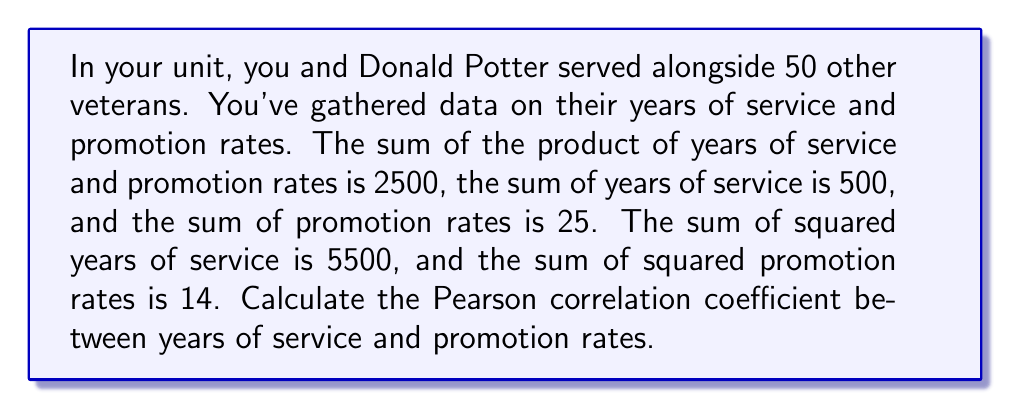Help me with this question. To calculate the Pearson correlation coefficient, we'll use the formula:

$$ r = \frac{n\sum xy - \sum x \sum y}{\sqrt{[n\sum x^2 - (\sum x)^2][n\sum y^2 - (\sum y)^2]}} $$

Where:
$x$ = years of service
$y$ = promotion rates
$n$ = number of veterans = 52 (including you and Donald Potter)

Given:
$\sum xy = 2500$
$\sum x = 500$
$\sum y = 25$
$\sum x^2 = 5500$
$\sum y^2 = 14$

Step 1: Calculate the numerator
$n\sum xy - \sum x \sum y = 52(2500) - 500(25) = 130,000 - 12,500 = 117,500$

Step 2: Calculate the first part of the denominator
$n\sum x^2 - (\sum x)^2 = 52(5500) - 500^2 = 286,000 - 250,000 = 36,000$

Step 3: Calculate the second part of the denominator
$n\sum y^2 - (\sum y)^2 = 52(14) - 25^2 = 728 - 625 = 103$

Step 4: Multiply the two parts of the denominator and take the square root
$\sqrt{36,000 \times 103} = \sqrt{3,708,000} \approx 1,925.62$

Step 5: Divide the numerator by the denominator
$r = \frac{117,500}{1,925.62} \approx 61.02$

Therefore, the Pearson correlation coefficient is approximately 61.02.
Answer: 61.02 